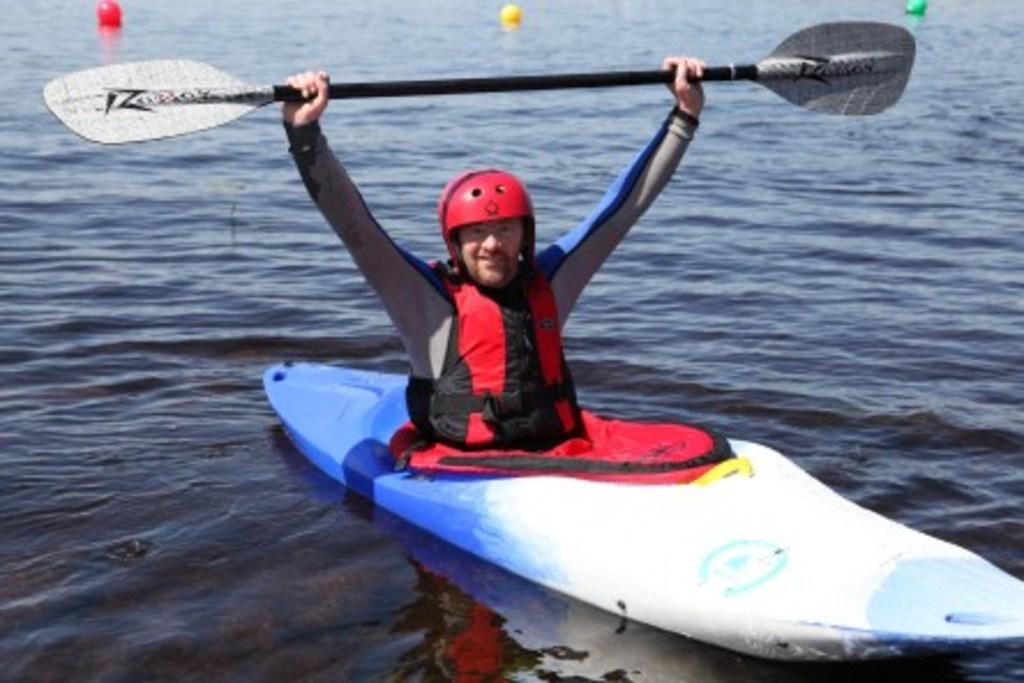What is the man in the image doing? The man is boating on the surface of the water. What is the man wearing on his head? The man is wearing a helmet. What is the man using to propel the boat? The man is holding a paddle. What can be seen in the background of the image? There are balls visible in the background of the image. What type of mist is surrounding the man in the image? There is no mist present in the image; it is a clear day with the man boating on the water. 